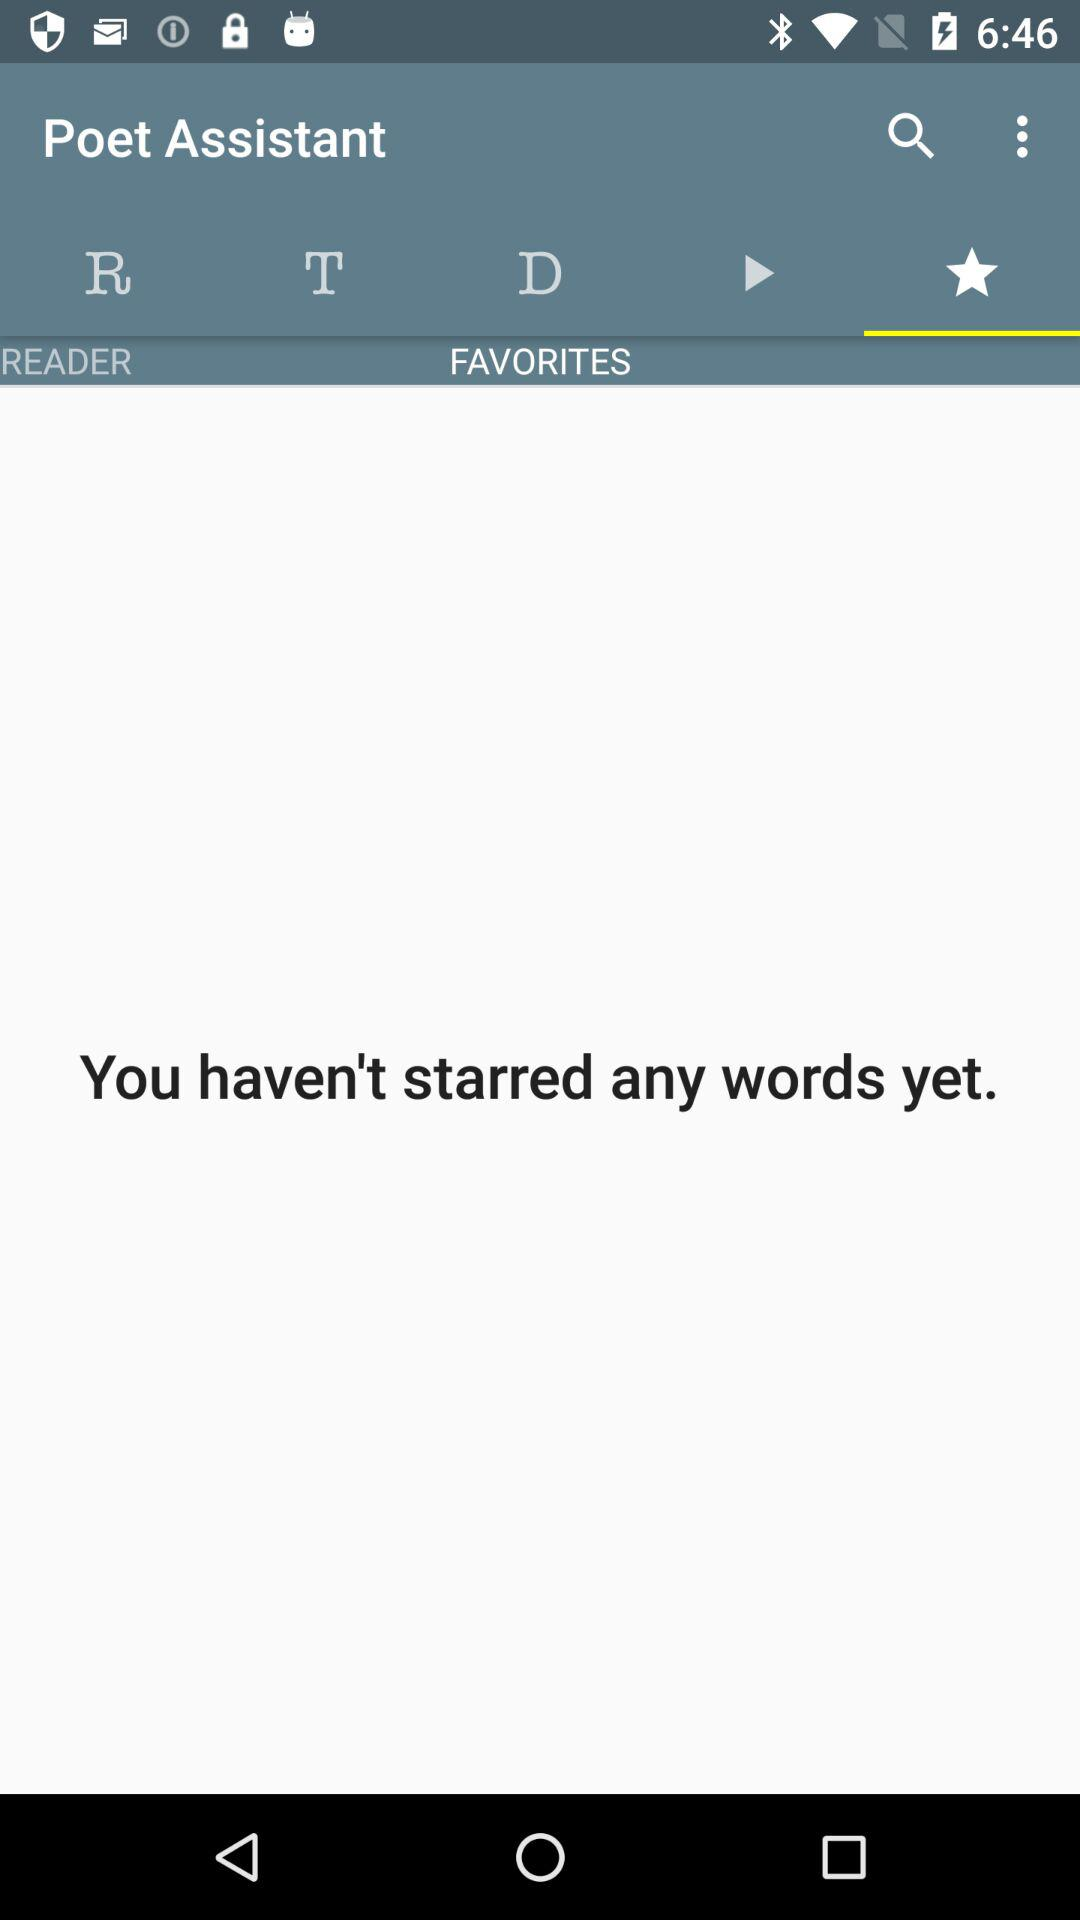Which tab is selected? The selected tab is "Starred". 